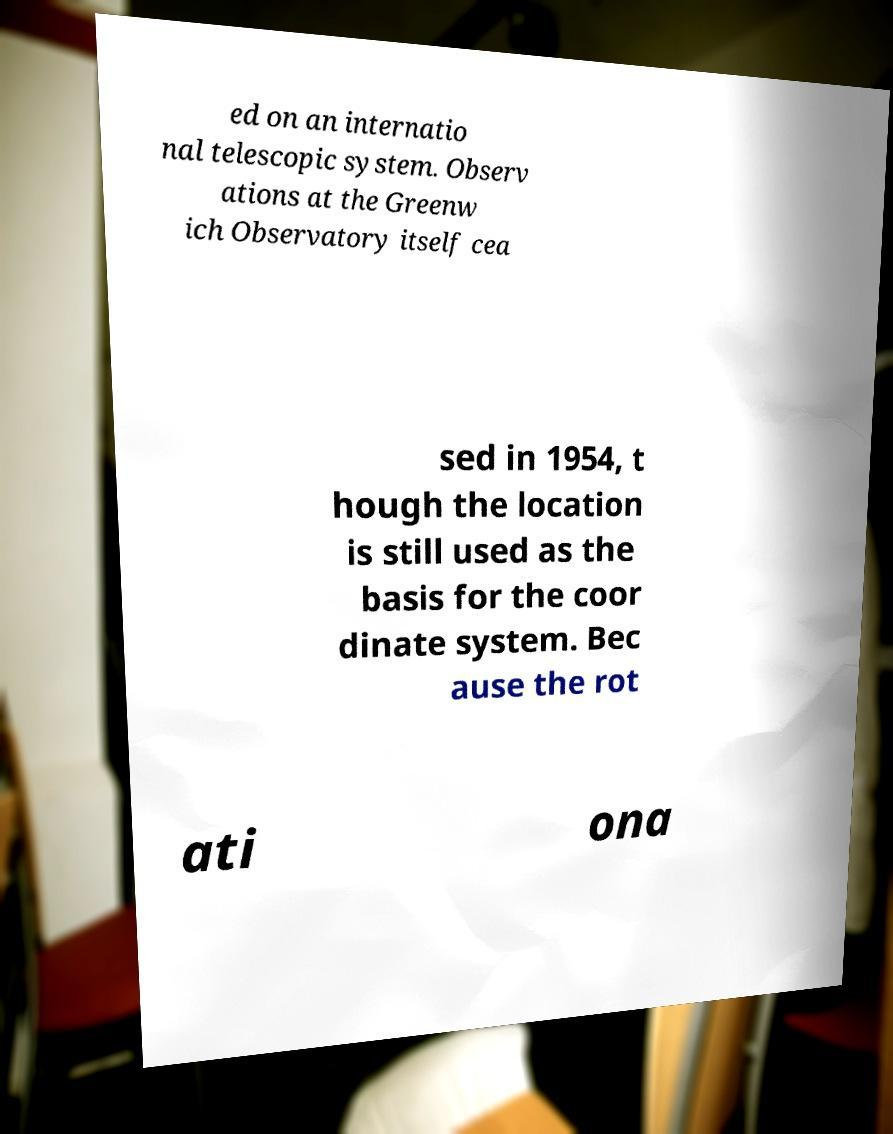Could you extract and type out the text from this image? ed on an internatio nal telescopic system. Observ ations at the Greenw ich Observatory itself cea sed in 1954, t hough the location is still used as the basis for the coor dinate system. Bec ause the rot ati ona 